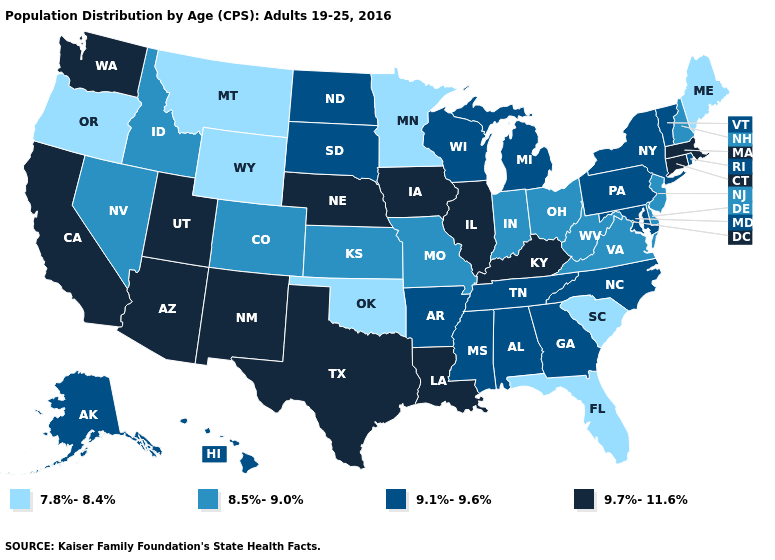How many symbols are there in the legend?
Write a very short answer. 4. What is the value of Louisiana?
Write a very short answer. 9.7%-11.6%. What is the value of Mississippi?
Write a very short answer. 9.1%-9.6%. Name the states that have a value in the range 8.5%-9.0%?
Short answer required. Colorado, Delaware, Idaho, Indiana, Kansas, Missouri, Nevada, New Hampshire, New Jersey, Ohio, Virginia, West Virginia. What is the lowest value in states that border Pennsylvania?
Concise answer only. 8.5%-9.0%. What is the value of Maryland?
Write a very short answer. 9.1%-9.6%. Name the states that have a value in the range 8.5%-9.0%?
Concise answer only. Colorado, Delaware, Idaho, Indiana, Kansas, Missouri, Nevada, New Hampshire, New Jersey, Ohio, Virginia, West Virginia. Does the map have missing data?
Be succinct. No. Name the states that have a value in the range 7.8%-8.4%?
Write a very short answer. Florida, Maine, Minnesota, Montana, Oklahoma, Oregon, South Carolina, Wyoming. What is the value of Arkansas?
Short answer required. 9.1%-9.6%. Does the map have missing data?
Be succinct. No. Is the legend a continuous bar?
Answer briefly. No. Name the states that have a value in the range 9.7%-11.6%?
Short answer required. Arizona, California, Connecticut, Illinois, Iowa, Kentucky, Louisiana, Massachusetts, Nebraska, New Mexico, Texas, Utah, Washington. Which states have the lowest value in the West?
Answer briefly. Montana, Oregon, Wyoming. 